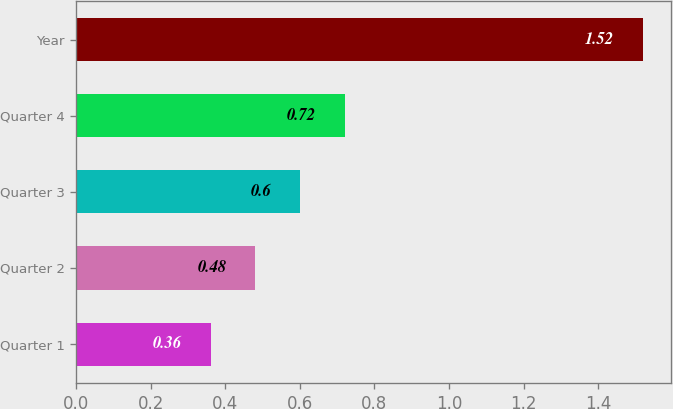Convert chart. <chart><loc_0><loc_0><loc_500><loc_500><bar_chart><fcel>Quarter 1<fcel>Quarter 2<fcel>Quarter 3<fcel>Quarter 4<fcel>Year<nl><fcel>0.36<fcel>0.48<fcel>0.6<fcel>0.72<fcel>1.52<nl></chart> 